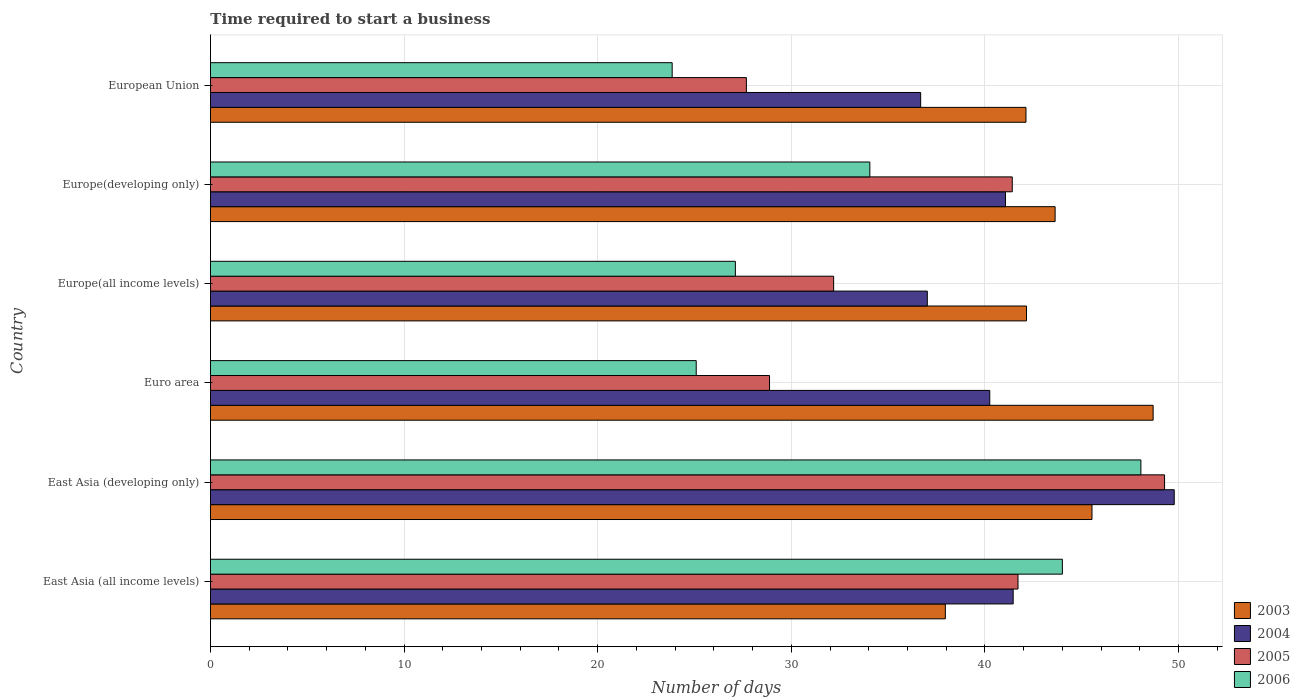How many different coloured bars are there?
Provide a short and direct response. 4. Are the number of bars per tick equal to the number of legend labels?
Offer a terse response. Yes. Are the number of bars on each tick of the Y-axis equal?
Your response must be concise. Yes. How many bars are there on the 3rd tick from the top?
Keep it short and to the point. 4. How many bars are there on the 5th tick from the bottom?
Your answer should be very brief. 4. What is the number of days required to start a business in 2003 in East Asia (all income levels)?
Ensure brevity in your answer.  37.96. Across all countries, what is the maximum number of days required to start a business in 2006?
Your answer should be compact. 48.06. Across all countries, what is the minimum number of days required to start a business in 2003?
Provide a short and direct response. 37.96. In which country was the number of days required to start a business in 2006 maximum?
Provide a short and direct response. East Asia (developing only). What is the total number of days required to start a business in 2006 in the graph?
Give a very brief answer. 202.16. What is the difference between the number of days required to start a business in 2003 in East Asia (developing only) and that in Europe(developing only)?
Give a very brief answer. 1.9. What is the difference between the number of days required to start a business in 2005 in Europe(all income levels) and the number of days required to start a business in 2003 in European Union?
Your answer should be compact. -9.93. What is the average number of days required to start a business in 2005 per country?
Offer a terse response. 36.86. What is the difference between the number of days required to start a business in 2004 and number of days required to start a business in 2005 in Euro area?
Give a very brief answer. 11.38. In how many countries, is the number of days required to start a business in 2005 greater than 48 days?
Provide a short and direct response. 1. What is the ratio of the number of days required to start a business in 2003 in East Asia (all income levels) to that in Europe(developing only)?
Make the answer very short. 0.87. Is the difference between the number of days required to start a business in 2004 in Europe(all income levels) and Europe(developing only) greater than the difference between the number of days required to start a business in 2005 in Europe(all income levels) and Europe(developing only)?
Offer a terse response. Yes. What is the difference between the highest and the second highest number of days required to start a business in 2005?
Your answer should be compact. 7.57. What is the difference between the highest and the lowest number of days required to start a business in 2006?
Ensure brevity in your answer.  24.21. What does the 3rd bar from the top in Europe(all income levels) represents?
Your answer should be compact. 2004. How many countries are there in the graph?
Provide a short and direct response. 6. What is the difference between two consecutive major ticks on the X-axis?
Offer a very short reply. 10. Are the values on the major ticks of X-axis written in scientific E-notation?
Offer a very short reply. No. Does the graph contain any zero values?
Provide a succinct answer. No. What is the title of the graph?
Make the answer very short. Time required to start a business. Does "1996" appear as one of the legend labels in the graph?
Offer a terse response. No. What is the label or title of the X-axis?
Keep it short and to the point. Number of days. What is the label or title of the Y-axis?
Make the answer very short. Country. What is the Number of days of 2003 in East Asia (all income levels)?
Provide a succinct answer. 37.96. What is the Number of days of 2004 in East Asia (all income levels)?
Your answer should be very brief. 41.46. What is the Number of days in 2005 in East Asia (all income levels)?
Ensure brevity in your answer.  41.71. What is the Number of days in 2003 in East Asia (developing only)?
Ensure brevity in your answer.  45.53. What is the Number of days in 2004 in East Asia (developing only)?
Provide a short and direct response. 49.78. What is the Number of days of 2005 in East Asia (developing only)?
Your response must be concise. 49.28. What is the Number of days in 2006 in East Asia (developing only)?
Offer a terse response. 48.06. What is the Number of days of 2003 in Euro area?
Make the answer very short. 48.69. What is the Number of days in 2004 in Euro area?
Your answer should be compact. 40.25. What is the Number of days of 2005 in Euro area?
Your answer should be very brief. 28.88. What is the Number of days of 2006 in Euro area?
Your answer should be very brief. 25.09. What is the Number of days in 2003 in Europe(all income levels)?
Your answer should be very brief. 42.15. What is the Number of days in 2004 in Europe(all income levels)?
Your answer should be compact. 37.02. What is the Number of days in 2005 in Europe(all income levels)?
Give a very brief answer. 32.19. What is the Number of days in 2006 in Europe(all income levels)?
Provide a short and direct response. 27.11. What is the Number of days of 2003 in Europe(developing only)?
Provide a succinct answer. 43.62. What is the Number of days in 2004 in Europe(developing only)?
Give a very brief answer. 41.06. What is the Number of days of 2005 in Europe(developing only)?
Your answer should be compact. 41.41. What is the Number of days in 2006 in Europe(developing only)?
Keep it short and to the point. 34.06. What is the Number of days of 2003 in European Union?
Make the answer very short. 42.12. What is the Number of days in 2004 in European Union?
Offer a very short reply. 36.68. What is the Number of days in 2005 in European Union?
Offer a terse response. 27.68. What is the Number of days in 2006 in European Union?
Provide a succinct answer. 23.85. Across all countries, what is the maximum Number of days in 2003?
Give a very brief answer. 48.69. Across all countries, what is the maximum Number of days of 2004?
Provide a short and direct response. 49.78. Across all countries, what is the maximum Number of days of 2005?
Your answer should be compact. 49.28. Across all countries, what is the maximum Number of days of 2006?
Provide a succinct answer. 48.06. Across all countries, what is the minimum Number of days in 2003?
Make the answer very short. 37.96. Across all countries, what is the minimum Number of days of 2004?
Your answer should be very brief. 36.68. Across all countries, what is the minimum Number of days in 2005?
Offer a very short reply. 27.68. Across all countries, what is the minimum Number of days in 2006?
Provide a succinct answer. 23.85. What is the total Number of days in 2003 in the graph?
Make the answer very short. 260.06. What is the total Number of days in 2004 in the graph?
Ensure brevity in your answer.  246.25. What is the total Number of days in 2005 in the graph?
Your answer should be very brief. 221.14. What is the total Number of days of 2006 in the graph?
Keep it short and to the point. 202.16. What is the difference between the Number of days in 2003 in East Asia (all income levels) and that in East Asia (developing only)?
Your answer should be very brief. -7.57. What is the difference between the Number of days of 2004 in East Asia (all income levels) and that in East Asia (developing only)?
Your response must be concise. -8.32. What is the difference between the Number of days in 2005 in East Asia (all income levels) and that in East Asia (developing only)?
Offer a very short reply. -7.57. What is the difference between the Number of days in 2006 in East Asia (all income levels) and that in East Asia (developing only)?
Keep it short and to the point. -4.06. What is the difference between the Number of days in 2003 in East Asia (all income levels) and that in Euro area?
Ensure brevity in your answer.  -10.73. What is the difference between the Number of days of 2004 in East Asia (all income levels) and that in Euro area?
Provide a succinct answer. 1.21. What is the difference between the Number of days in 2005 in East Asia (all income levels) and that in Euro area?
Offer a terse response. 12.83. What is the difference between the Number of days of 2006 in East Asia (all income levels) and that in Euro area?
Provide a succinct answer. 18.91. What is the difference between the Number of days of 2003 in East Asia (all income levels) and that in Europe(all income levels)?
Offer a very short reply. -4.19. What is the difference between the Number of days in 2004 in East Asia (all income levels) and that in Europe(all income levels)?
Provide a succinct answer. 4.43. What is the difference between the Number of days of 2005 in East Asia (all income levels) and that in Europe(all income levels)?
Provide a succinct answer. 9.52. What is the difference between the Number of days in 2006 in East Asia (all income levels) and that in Europe(all income levels)?
Give a very brief answer. 16.89. What is the difference between the Number of days in 2003 in East Asia (all income levels) and that in Europe(developing only)?
Your response must be concise. -5.67. What is the difference between the Number of days in 2004 in East Asia (all income levels) and that in Europe(developing only)?
Your answer should be very brief. 0.4. What is the difference between the Number of days in 2005 in East Asia (all income levels) and that in Europe(developing only)?
Provide a short and direct response. 0.3. What is the difference between the Number of days of 2006 in East Asia (all income levels) and that in Europe(developing only)?
Ensure brevity in your answer.  9.94. What is the difference between the Number of days in 2003 in East Asia (all income levels) and that in European Union?
Make the answer very short. -4.16. What is the difference between the Number of days of 2004 in East Asia (all income levels) and that in European Union?
Make the answer very short. 4.78. What is the difference between the Number of days in 2005 in East Asia (all income levels) and that in European Union?
Ensure brevity in your answer.  14.03. What is the difference between the Number of days of 2006 in East Asia (all income levels) and that in European Union?
Keep it short and to the point. 20.15. What is the difference between the Number of days of 2003 in East Asia (developing only) and that in Euro area?
Give a very brief answer. -3.16. What is the difference between the Number of days of 2004 in East Asia (developing only) and that in Euro area?
Offer a very short reply. 9.53. What is the difference between the Number of days in 2005 in East Asia (developing only) and that in Euro area?
Ensure brevity in your answer.  20.4. What is the difference between the Number of days of 2006 in East Asia (developing only) and that in Euro area?
Keep it short and to the point. 22.97. What is the difference between the Number of days of 2003 in East Asia (developing only) and that in Europe(all income levels)?
Keep it short and to the point. 3.38. What is the difference between the Number of days of 2004 in East Asia (developing only) and that in Europe(all income levels)?
Make the answer very short. 12.75. What is the difference between the Number of days of 2005 in East Asia (developing only) and that in Europe(all income levels)?
Keep it short and to the point. 17.09. What is the difference between the Number of days in 2006 in East Asia (developing only) and that in Europe(all income levels)?
Give a very brief answer. 20.94. What is the difference between the Number of days of 2003 in East Asia (developing only) and that in Europe(developing only)?
Give a very brief answer. 1.9. What is the difference between the Number of days of 2004 in East Asia (developing only) and that in Europe(developing only)?
Your answer should be compact. 8.72. What is the difference between the Number of days in 2005 in East Asia (developing only) and that in Europe(developing only)?
Ensure brevity in your answer.  7.87. What is the difference between the Number of days of 2006 in East Asia (developing only) and that in Europe(developing only)?
Offer a terse response. 14. What is the difference between the Number of days of 2003 in East Asia (developing only) and that in European Union?
Keep it short and to the point. 3.41. What is the difference between the Number of days in 2004 in East Asia (developing only) and that in European Union?
Your response must be concise. 13.1. What is the difference between the Number of days in 2005 in East Asia (developing only) and that in European Union?
Ensure brevity in your answer.  21.6. What is the difference between the Number of days of 2006 in East Asia (developing only) and that in European Union?
Your answer should be compact. 24.21. What is the difference between the Number of days of 2003 in Euro area and that in Europe(all income levels)?
Your answer should be compact. 6.54. What is the difference between the Number of days of 2004 in Euro area and that in Europe(all income levels)?
Ensure brevity in your answer.  3.23. What is the difference between the Number of days of 2005 in Euro area and that in Europe(all income levels)?
Provide a succinct answer. -3.31. What is the difference between the Number of days in 2006 in Euro area and that in Europe(all income levels)?
Provide a succinct answer. -2.02. What is the difference between the Number of days of 2003 in Euro area and that in Europe(developing only)?
Your answer should be very brief. 5.06. What is the difference between the Number of days in 2004 in Euro area and that in Europe(developing only)?
Offer a very short reply. -0.81. What is the difference between the Number of days in 2005 in Euro area and that in Europe(developing only)?
Keep it short and to the point. -12.54. What is the difference between the Number of days in 2006 in Euro area and that in Europe(developing only)?
Offer a very short reply. -8.97. What is the difference between the Number of days of 2003 in Euro area and that in European Union?
Your answer should be compact. 6.57. What is the difference between the Number of days of 2004 in Euro area and that in European Union?
Keep it short and to the point. 3.57. What is the difference between the Number of days of 2005 in Euro area and that in European Union?
Offer a terse response. 1.2. What is the difference between the Number of days of 2006 in Euro area and that in European Union?
Provide a succinct answer. 1.24. What is the difference between the Number of days in 2003 in Europe(all income levels) and that in Europe(developing only)?
Provide a succinct answer. -1.48. What is the difference between the Number of days of 2004 in Europe(all income levels) and that in Europe(developing only)?
Your answer should be very brief. -4.04. What is the difference between the Number of days of 2005 in Europe(all income levels) and that in Europe(developing only)?
Ensure brevity in your answer.  -9.23. What is the difference between the Number of days in 2006 in Europe(all income levels) and that in Europe(developing only)?
Ensure brevity in your answer.  -6.94. What is the difference between the Number of days in 2003 in Europe(all income levels) and that in European Union?
Make the answer very short. 0.03. What is the difference between the Number of days of 2004 in Europe(all income levels) and that in European Union?
Your response must be concise. 0.34. What is the difference between the Number of days in 2005 in Europe(all income levels) and that in European Union?
Your answer should be very brief. 4.51. What is the difference between the Number of days in 2006 in Europe(all income levels) and that in European Union?
Make the answer very short. 3.27. What is the difference between the Number of days of 2003 in Europe(developing only) and that in European Union?
Provide a short and direct response. 1.5. What is the difference between the Number of days in 2004 in Europe(developing only) and that in European Union?
Give a very brief answer. 4.38. What is the difference between the Number of days in 2005 in Europe(developing only) and that in European Union?
Keep it short and to the point. 13.73. What is the difference between the Number of days in 2006 in Europe(developing only) and that in European Union?
Offer a very short reply. 10.21. What is the difference between the Number of days in 2003 in East Asia (all income levels) and the Number of days in 2004 in East Asia (developing only)?
Offer a very short reply. -11.82. What is the difference between the Number of days in 2003 in East Asia (all income levels) and the Number of days in 2005 in East Asia (developing only)?
Your answer should be very brief. -11.32. What is the difference between the Number of days of 2003 in East Asia (all income levels) and the Number of days of 2006 in East Asia (developing only)?
Your answer should be compact. -10.1. What is the difference between the Number of days in 2004 in East Asia (all income levels) and the Number of days in 2005 in East Asia (developing only)?
Your answer should be very brief. -7.82. What is the difference between the Number of days in 2004 in East Asia (all income levels) and the Number of days in 2006 in East Asia (developing only)?
Your response must be concise. -6.6. What is the difference between the Number of days of 2005 in East Asia (all income levels) and the Number of days of 2006 in East Asia (developing only)?
Your answer should be compact. -6.35. What is the difference between the Number of days of 2003 in East Asia (all income levels) and the Number of days of 2004 in Euro area?
Provide a succinct answer. -2.29. What is the difference between the Number of days in 2003 in East Asia (all income levels) and the Number of days in 2005 in Euro area?
Your answer should be very brief. 9.08. What is the difference between the Number of days in 2003 in East Asia (all income levels) and the Number of days in 2006 in Euro area?
Offer a terse response. 12.87. What is the difference between the Number of days of 2004 in East Asia (all income levels) and the Number of days of 2005 in Euro area?
Keep it short and to the point. 12.58. What is the difference between the Number of days in 2004 in East Asia (all income levels) and the Number of days in 2006 in Euro area?
Ensure brevity in your answer.  16.37. What is the difference between the Number of days of 2005 in East Asia (all income levels) and the Number of days of 2006 in Euro area?
Provide a succinct answer. 16.62. What is the difference between the Number of days in 2003 in East Asia (all income levels) and the Number of days in 2004 in Europe(all income levels)?
Give a very brief answer. 0.93. What is the difference between the Number of days in 2003 in East Asia (all income levels) and the Number of days in 2005 in Europe(all income levels)?
Keep it short and to the point. 5.77. What is the difference between the Number of days of 2003 in East Asia (all income levels) and the Number of days of 2006 in Europe(all income levels)?
Your answer should be compact. 10.85. What is the difference between the Number of days in 2004 in East Asia (all income levels) and the Number of days in 2005 in Europe(all income levels)?
Keep it short and to the point. 9.27. What is the difference between the Number of days in 2004 in East Asia (all income levels) and the Number of days in 2006 in Europe(all income levels)?
Your response must be concise. 14.35. What is the difference between the Number of days in 2005 in East Asia (all income levels) and the Number of days in 2006 in Europe(all income levels)?
Offer a very short reply. 14.6. What is the difference between the Number of days of 2003 in East Asia (all income levels) and the Number of days of 2004 in Europe(developing only)?
Offer a terse response. -3.11. What is the difference between the Number of days of 2003 in East Asia (all income levels) and the Number of days of 2005 in Europe(developing only)?
Ensure brevity in your answer.  -3.46. What is the difference between the Number of days of 2003 in East Asia (all income levels) and the Number of days of 2006 in Europe(developing only)?
Offer a very short reply. 3.9. What is the difference between the Number of days of 2004 in East Asia (all income levels) and the Number of days of 2005 in Europe(developing only)?
Make the answer very short. 0.05. What is the difference between the Number of days in 2004 in East Asia (all income levels) and the Number of days in 2006 in Europe(developing only)?
Provide a succinct answer. 7.4. What is the difference between the Number of days in 2005 in East Asia (all income levels) and the Number of days in 2006 in Europe(developing only)?
Offer a very short reply. 7.65. What is the difference between the Number of days of 2003 in East Asia (all income levels) and the Number of days of 2004 in European Union?
Provide a succinct answer. 1.28. What is the difference between the Number of days in 2003 in East Asia (all income levels) and the Number of days in 2005 in European Union?
Make the answer very short. 10.28. What is the difference between the Number of days of 2003 in East Asia (all income levels) and the Number of days of 2006 in European Union?
Provide a short and direct response. 14.11. What is the difference between the Number of days of 2004 in East Asia (all income levels) and the Number of days of 2005 in European Union?
Your response must be concise. 13.78. What is the difference between the Number of days of 2004 in East Asia (all income levels) and the Number of days of 2006 in European Union?
Provide a succinct answer. 17.61. What is the difference between the Number of days in 2005 in East Asia (all income levels) and the Number of days in 2006 in European Union?
Provide a short and direct response. 17.86. What is the difference between the Number of days in 2003 in East Asia (developing only) and the Number of days in 2004 in Euro area?
Your response must be concise. 5.28. What is the difference between the Number of days in 2003 in East Asia (developing only) and the Number of days in 2005 in Euro area?
Keep it short and to the point. 16.65. What is the difference between the Number of days of 2003 in East Asia (developing only) and the Number of days of 2006 in Euro area?
Offer a very short reply. 20.44. What is the difference between the Number of days of 2004 in East Asia (developing only) and the Number of days of 2005 in Euro area?
Give a very brief answer. 20.9. What is the difference between the Number of days in 2004 in East Asia (developing only) and the Number of days in 2006 in Euro area?
Keep it short and to the point. 24.69. What is the difference between the Number of days in 2005 in East Asia (developing only) and the Number of days in 2006 in Euro area?
Give a very brief answer. 24.19. What is the difference between the Number of days of 2003 in East Asia (developing only) and the Number of days of 2004 in Europe(all income levels)?
Your response must be concise. 8.51. What is the difference between the Number of days of 2003 in East Asia (developing only) and the Number of days of 2005 in Europe(all income levels)?
Make the answer very short. 13.34. What is the difference between the Number of days in 2003 in East Asia (developing only) and the Number of days in 2006 in Europe(all income levels)?
Your response must be concise. 18.42. What is the difference between the Number of days in 2004 in East Asia (developing only) and the Number of days in 2005 in Europe(all income levels)?
Offer a terse response. 17.59. What is the difference between the Number of days in 2004 in East Asia (developing only) and the Number of days in 2006 in Europe(all income levels)?
Your response must be concise. 22.67. What is the difference between the Number of days in 2005 in East Asia (developing only) and the Number of days in 2006 in Europe(all income levels)?
Make the answer very short. 22.17. What is the difference between the Number of days in 2003 in East Asia (developing only) and the Number of days in 2004 in Europe(developing only)?
Your answer should be very brief. 4.47. What is the difference between the Number of days in 2003 in East Asia (developing only) and the Number of days in 2005 in Europe(developing only)?
Provide a short and direct response. 4.12. What is the difference between the Number of days of 2003 in East Asia (developing only) and the Number of days of 2006 in Europe(developing only)?
Provide a short and direct response. 11.47. What is the difference between the Number of days in 2004 in East Asia (developing only) and the Number of days in 2005 in Europe(developing only)?
Your response must be concise. 8.37. What is the difference between the Number of days of 2004 in East Asia (developing only) and the Number of days of 2006 in Europe(developing only)?
Provide a short and direct response. 15.72. What is the difference between the Number of days in 2005 in East Asia (developing only) and the Number of days in 2006 in Europe(developing only)?
Ensure brevity in your answer.  15.22. What is the difference between the Number of days in 2003 in East Asia (developing only) and the Number of days in 2004 in European Union?
Keep it short and to the point. 8.85. What is the difference between the Number of days of 2003 in East Asia (developing only) and the Number of days of 2005 in European Union?
Provide a short and direct response. 17.85. What is the difference between the Number of days of 2003 in East Asia (developing only) and the Number of days of 2006 in European Union?
Make the answer very short. 21.68. What is the difference between the Number of days of 2004 in East Asia (developing only) and the Number of days of 2005 in European Union?
Your answer should be very brief. 22.1. What is the difference between the Number of days in 2004 in East Asia (developing only) and the Number of days in 2006 in European Union?
Offer a very short reply. 25.93. What is the difference between the Number of days in 2005 in East Asia (developing only) and the Number of days in 2006 in European Union?
Make the answer very short. 25.43. What is the difference between the Number of days of 2003 in Euro area and the Number of days of 2004 in Europe(all income levels)?
Keep it short and to the point. 11.66. What is the difference between the Number of days of 2003 in Euro area and the Number of days of 2005 in Europe(all income levels)?
Make the answer very short. 16.5. What is the difference between the Number of days of 2003 in Euro area and the Number of days of 2006 in Europe(all income levels)?
Make the answer very short. 21.58. What is the difference between the Number of days in 2004 in Euro area and the Number of days in 2005 in Europe(all income levels)?
Keep it short and to the point. 8.06. What is the difference between the Number of days of 2004 in Euro area and the Number of days of 2006 in Europe(all income levels)?
Provide a short and direct response. 13.14. What is the difference between the Number of days of 2005 in Euro area and the Number of days of 2006 in Europe(all income levels)?
Provide a succinct answer. 1.76. What is the difference between the Number of days in 2003 in Euro area and the Number of days in 2004 in Europe(developing only)?
Your answer should be compact. 7.62. What is the difference between the Number of days in 2003 in Euro area and the Number of days in 2005 in Europe(developing only)?
Your answer should be compact. 7.28. What is the difference between the Number of days in 2003 in Euro area and the Number of days in 2006 in Europe(developing only)?
Offer a terse response. 14.63. What is the difference between the Number of days of 2004 in Euro area and the Number of days of 2005 in Europe(developing only)?
Your answer should be very brief. -1.16. What is the difference between the Number of days in 2004 in Euro area and the Number of days in 2006 in Europe(developing only)?
Offer a terse response. 6.19. What is the difference between the Number of days of 2005 in Euro area and the Number of days of 2006 in Europe(developing only)?
Your response must be concise. -5.18. What is the difference between the Number of days in 2003 in Euro area and the Number of days in 2004 in European Union?
Provide a succinct answer. 12.01. What is the difference between the Number of days of 2003 in Euro area and the Number of days of 2005 in European Union?
Give a very brief answer. 21.01. What is the difference between the Number of days of 2003 in Euro area and the Number of days of 2006 in European Union?
Your response must be concise. 24.84. What is the difference between the Number of days in 2004 in Euro area and the Number of days in 2005 in European Union?
Ensure brevity in your answer.  12.57. What is the difference between the Number of days in 2004 in Euro area and the Number of days in 2006 in European Union?
Make the answer very short. 16.4. What is the difference between the Number of days in 2005 in Euro area and the Number of days in 2006 in European Union?
Your answer should be very brief. 5.03. What is the difference between the Number of days in 2003 in Europe(all income levels) and the Number of days in 2004 in Europe(developing only)?
Your answer should be compact. 1.08. What is the difference between the Number of days in 2003 in Europe(all income levels) and the Number of days in 2005 in Europe(developing only)?
Your answer should be very brief. 0.73. What is the difference between the Number of days of 2003 in Europe(all income levels) and the Number of days of 2006 in Europe(developing only)?
Your answer should be compact. 8.09. What is the difference between the Number of days of 2004 in Europe(all income levels) and the Number of days of 2005 in Europe(developing only)?
Provide a succinct answer. -4.39. What is the difference between the Number of days in 2004 in Europe(all income levels) and the Number of days in 2006 in Europe(developing only)?
Your answer should be very brief. 2.97. What is the difference between the Number of days in 2005 in Europe(all income levels) and the Number of days in 2006 in Europe(developing only)?
Offer a very short reply. -1.87. What is the difference between the Number of days of 2003 in Europe(all income levels) and the Number of days of 2004 in European Union?
Your answer should be very brief. 5.47. What is the difference between the Number of days of 2003 in Europe(all income levels) and the Number of days of 2005 in European Union?
Offer a very short reply. 14.47. What is the difference between the Number of days of 2003 in Europe(all income levels) and the Number of days of 2006 in European Union?
Offer a terse response. 18.3. What is the difference between the Number of days of 2004 in Europe(all income levels) and the Number of days of 2005 in European Union?
Ensure brevity in your answer.  9.34. What is the difference between the Number of days of 2004 in Europe(all income levels) and the Number of days of 2006 in European Union?
Keep it short and to the point. 13.18. What is the difference between the Number of days of 2005 in Europe(all income levels) and the Number of days of 2006 in European Union?
Your answer should be compact. 8.34. What is the difference between the Number of days of 2003 in Europe(developing only) and the Number of days of 2004 in European Union?
Provide a succinct answer. 6.95. What is the difference between the Number of days in 2003 in Europe(developing only) and the Number of days in 2005 in European Union?
Provide a succinct answer. 15.95. What is the difference between the Number of days of 2003 in Europe(developing only) and the Number of days of 2006 in European Union?
Your answer should be very brief. 19.78. What is the difference between the Number of days of 2004 in Europe(developing only) and the Number of days of 2005 in European Union?
Your answer should be very brief. 13.38. What is the difference between the Number of days in 2004 in Europe(developing only) and the Number of days in 2006 in European Union?
Ensure brevity in your answer.  17.22. What is the difference between the Number of days of 2005 in Europe(developing only) and the Number of days of 2006 in European Union?
Offer a terse response. 17.57. What is the average Number of days in 2003 per country?
Provide a short and direct response. 43.34. What is the average Number of days in 2004 per country?
Your response must be concise. 41.04. What is the average Number of days of 2005 per country?
Keep it short and to the point. 36.86. What is the average Number of days in 2006 per country?
Offer a very short reply. 33.69. What is the difference between the Number of days of 2003 and Number of days of 2004 in East Asia (all income levels)?
Your answer should be compact. -3.5. What is the difference between the Number of days in 2003 and Number of days in 2005 in East Asia (all income levels)?
Offer a very short reply. -3.75. What is the difference between the Number of days of 2003 and Number of days of 2006 in East Asia (all income levels)?
Your answer should be compact. -6.04. What is the difference between the Number of days of 2004 and Number of days of 2006 in East Asia (all income levels)?
Provide a short and direct response. -2.54. What is the difference between the Number of days of 2005 and Number of days of 2006 in East Asia (all income levels)?
Provide a short and direct response. -2.29. What is the difference between the Number of days of 2003 and Number of days of 2004 in East Asia (developing only)?
Ensure brevity in your answer.  -4.25. What is the difference between the Number of days of 2003 and Number of days of 2005 in East Asia (developing only)?
Ensure brevity in your answer.  -3.75. What is the difference between the Number of days in 2003 and Number of days in 2006 in East Asia (developing only)?
Offer a very short reply. -2.53. What is the difference between the Number of days in 2004 and Number of days in 2005 in East Asia (developing only)?
Make the answer very short. 0.5. What is the difference between the Number of days of 2004 and Number of days of 2006 in East Asia (developing only)?
Provide a short and direct response. 1.72. What is the difference between the Number of days in 2005 and Number of days in 2006 in East Asia (developing only)?
Provide a succinct answer. 1.22. What is the difference between the Number of days of 2003 and Number of days of 2004 in Euro area?
Provide a succinct answer. 8.44. What is the difference between the Number of days of 2003 and Number of days of 2005 in Euro area?
Your response must be concise. 19.81. What is the difference between the Number of days in 2003 and Number of days in 2006 in Euro area?
Give a very brief answer. 23.6. What is the difference between the Number of days of 2004 and Number of days of 2005 in Euro area?
Offer a very short reply. 11.38. What is the difference between the Number of days in 2004 and Number of days in 2006 in Euro area?
Provide a succinct answer. 15.16. What is the difference between the Number of days in 2005 and Number of days in 2006 in Euro area?
Your answer should be compact. 3.79. What is the difference between the Number of days of 2003 and Number of days of 2004 in Europe(all income levels)?
Ensure brevity in your answer.  5.12. What is the difference between the Number of days in 2003 and Number of days in 2005 in Europe(all income levels)?
Make the answer very short. 9.96. What is the difference between the Number of days of 2003 and Number of days of 2006 in Europe(all income levels)?
Make the answer very short. 15.04. What is the difference between the Number of days in 2004 and Number of days in 2005 in Europe(all income levels)?
Offer a terse response. 4.84. What is the difference between the Number of days of 2004 and Number of days of 2006 in Europe(all income levels)?
Provide a succinct answer. 9.91. What is the difference between the Number of days of 2005 and Number of days of 2006 in Europe(all income levels)?
Your response must be concise. 5.07. What is the difference between the Number of days of 2003 and Number of days of 2004 in Europe(developing only)?
Provide a short and direct response. 2.56. What is the difference between the Number of days in 2003 and Number of days in 2005 in Europe(developing only)?
Ensure brevity in your answer.  2.21. What is the difference between the Number of days in 2003 and Number of days in 2006 in Europe(developing only)?
Offer a very short reply. 9.57. What is the difference between the Number of days in 2004 and Number of days in 2005 in Europe(developing only)?
Provide a succinct answer. -0.35. What is the difference between the Number of days in 2004 and Number of days in 2006 in Europe(developing only)?
Your answer should be very brief. 7.01. What is the difference between the Number of days of 2005 and Number of days of 2006 in Europe(developing only)?
Make the answer very short. 7.36. What is the difference between the Number of days of 2003 and Number of days of 2004 in European Union?
Make the answer very short. 5.44. What is the difference between the Number of days in 2003 and Number of days in 2005 in European Union?
Your response must be concise. 14.44. What is the difference between the Number of days of 2003 and Number of days of 2006 in European Union?
Provide a short and direct response. 18.27. What is the difference between the Number of days of 2004 and Number of days of 2005 in European Union?
Make the answer very short. 9. What is the difference between the Number of days of 2004 and Number of days of 2006 in European Union?
Give a very brief answer. 12.83. What is the difference between the Number of days of 2005 and Number of days of 2006 in European Union?
Ensure brevity in your answer.  3.83. What is the ratio of the Number of days of 2003 in East Asia (all income levels) to that in East Asia (developing only)?
Offer a terse response. 0.83. What is the ratio of the Number of days in 2004 in East Asia (all income levels) to that in East Asia (developing only)?
Your answer should be compact. 0.83. What is the ratio of the Number of days of 2005 in East Asia (all income levels) to that in East Asia (developing only)?
Your response must be concise. 0.85. What is the ratio of the Number of days in 2006 in East Asia (all income levels) to that in East Asia (developing only)?
Your answer should be compact. 0.92. What is the ratio of the Number of days of 2003 in East Asia (all income levels) to that in Euro area?
Your response must be concise. 0.78. What is the ratio of the Number of days in 2004 in East Asia (all income levels) to that in Euro area?
Make the answer very short. 1.03. What is the ratio of the Number of days of 2005 in East Asia (all income levels) to that in Euro area?
Keep it short and to the point. 1.44. What is the ratio of the Number of days in 2006 in East Asia (all income levels) to that in Euro area?
Offer a terse response. 1.75. What is the ratio of the Number of days in 2003 in East Asia (all income levels) to that in Europe(all income levels)?
Give a very brief answer. 0.9. What is the ratio of the Number of days in 2004 in East Asia (all income levels) to that in Europe(all income levels)?
Keep it short and to the point. 1.12. What is the ratio of the Number of days in 2005 in East Asia (all income levels) to that in Europe(all income levels)?
Keep it short and to the point. 1.3. What is the ratio of the Number of days of 2006 in East Asia (all income levels) to that in Europe(all income levels)?
Provide a succinct answer. 1.62. What is the ratio of the Number of days in 2003 in East Asia (all income levels) to that in Europe(developing only)?
Make the answer very short. 0.87. What is the ratio of the Number of days of 2004 in East Asia (all income levels) to that in Europe(developing only)?
Your answer should be compact. 1.01. What is the ratio of the Number of days in 2006 in East Asia (all income levels) to that in Europe(developing only)?
Provide a succinct answer. 1.29. What is the ratio of the Number of days of 2003 in East Asia (all income levels) to that in European Union?
Provide a short and direct response. 0.9. What is the ratio of the Number of days in 2004 in East Asia (all income levels) to that in European Union?
Your response must be concise. 1.13. What is the ratio of the Number of days in 2005 in East Asia (all income levels) to that in European Union?
Make the answer very short. 1.51. What is the ratio of the Number of days in 2006 in East Asia (all income levels) to that in European Union?
Your response must be concise. 1.85. What is the ratio of the Number of days in 2003 in East Asia (developing only) to that in Euro area?
Ensure brevity in your answer.  0.94. What is the ratio of the Number of days in 2004 in East Asia (developing only) to that in Euro area?
Provide a short and direct response. 1.24. What is the ratio of the Number of days in 2005 in East Asia (developing only) to that in Euro area?
Provide a short and direct response. 1.71. What is the ratio of the Number of days of 2006 in East Asia (developing only) to that in Euro area?
Make the answer very short. 1.92. What is the ratio of the Number of days of 2003 in East Asia (developing only) to that in Europe(all income levels)?
Your answer should be compact. 1.08. What is the ratio of the Number of days of 2004 in East Asia (developing only) to that in Europe(all income levels)?
Provide a short and direct response. 1.34. What is the ratio of the Number of days in 2005 in East Asia (developing only) to that in Europe(all income levels)?
Give a very brief answer. 1.53. What is the ratio of the Number of days of 2006 in East Asia (developing only) to that in Europe(all income levels)?
Give a very brief answer. 1.77. What is the ratio of the Number of days of 2003 in East Asia (developing only) to that in Europe(developing only)?
Keep it short and to the point. 1.04. What is the ratio of the Number of days in 2004 in East Asia (developing only) to that in Europe(developing only)?
Your answer should be compact. 1.21. What is the ratio of the Number of days of 2005 in East Asia (developing only) to that in Europe(developing only)?
Provide a short and direct response. 1.19. What is the ratio of the Number of days in 2006 in East Asia (developing only) to that in Europe(developing only)?
Provide a short and direct response. 1.41. What is the ratio of the Number of days in 2003 in East Asia (developing only) to that in European Union?
Your answer should be very brief. 1.08. What is the ratio of the Number of days in 2004 in East Asia (developing only) to that in European Union?
Ensure brevity in your answer.  1.36. What is the ratio of the Number of days in 2005 in East Asia (developing only) to that in European Union?
Give a very brief answer. 1.78. What is the ratio of the Number of days in 2006 in East Asia (developing only) to that in European Union?
Provide a short and direct response. 2.02. What is the ratio of the Number of days in 2003 in Euro area to that in Europe(all income levels)?
Your answer should be compact. 1.16. What is the ratio of the Number of days in 2004 in Euro area to that in Europe(all income levels)?
Your answer should be compact. 1.09. What is the ratio of the Number of days in 2005 in Euro area to that in Europe(all income levels)?
Provide a short and direct response. 0.9. What is the ratio of the Number of days of 2006 in Euro area to that in Europe(all income levels)?
Ensure brevity in your answer.  0.93. What is the ratio of the Number of days of 2003 in Euro area to that in Europe(developing only)?
Offer a very short reply. 1.12. What is the ratio of the Number of days in 2004 in Euro area to that in Europe(developing only)?
Make the answer very short. 0.98. What is the ratio of the Number of days in 2005 in Euro area to that in Europe(developing only)?
Your response must be concise. 0.7. What is the ratio of the Number of days of 2006 in Euro area to that in Europe(developing only)?
Give a very brief answer. 0.74. What is the ratio of the Number of days of 2003 in Euro area to that in European Union?
Offer a very short reply. 1.16. What is the ratio of the Number of days in 2004 in Euro area to that in European Union?
Provide a short and direct response. 1.1. What is the ratio of the Number of days of 2005 in Euro area to that in European Union?
Your answer should be compact. 1.04. What is the ratio of the Number of days of 2006 in Euro area to that in European Union?
Offer a very short reply. 1.05. What is the ratio of the Number of days in 2003 in Europe(all income levels) to that in Europe(developing only)?
Give a very brief answer. 0.97. What is the ratio of the Number of days in 2004 in Europe(all income levels) to that in Europe(developing only)?
Offer a very short reply. 0.9. What is the ratio of the Number of days in 2005 in Europe(all income levels) to that in Europe(developing only)?
Provide a succinct answer. 0.78. What is the ratio of the Number of days of 2006 in Europe(all income levels) to that in Europe(developing only)?
Ensure brevity in your answer.  0.8. What is the ratio of the Number of days in 2004 in Europe(all income levels) to that in European Union?
Offer a terse response. 1.01. What is the ratio of the Number of days of 2005 in Europe(all income levels) to that in European Union?
Your answer should be very brief. 1.16. What is the ratio of the Number of days of 2006 in Europe(all income levels) to that in European Union?
Your answer should be compact. 1.14. What is the ratio of the Number of days of 2003 in Europe(developing only) to that in European Union?
Provide a short and direct response. 1.04. What is the ratio of the Number of days in 2004 in Europe(developing only) to that in European Union?
Keep it short and to the point. 1.12. What is the ratio of the Number of days of 2005 in Europe(developing only) to that in European Union?
Offer a terse response. 1.5. What is the ratio of the Number of days of 2006 in Europe(developing only) to that in European Union?
Keep it short and to the point. 1.43. What is the difference between the highest and the second highest Number of days of 2003?
Give a very brief answer. 3.16. What is the difference between the highest and the second highest Number of days in 2004?
Give a very brief answer. 8.32. What is the difference between the highest and the second highest Number of days in 2005?
Offer a very short reply. 7.57. What is the difference between the highest and the second highest Number of days in 2006?
Keep it short and to the point. 4.06. What is the difference between the highest and the lowest Number of days in 2003?
Offer a very short reply. 10.73. What is the difference between the highest and the lowest Number of days in 2004?
Ensure brevity in your answer.  13.1. What is the difference between the highest and the lowest Number of days in 2005?
Keep it short and to the point. 21.6. What is the difference between the highest and the lowest Number of days in 2006?
Make the answer very short. 24.21. 